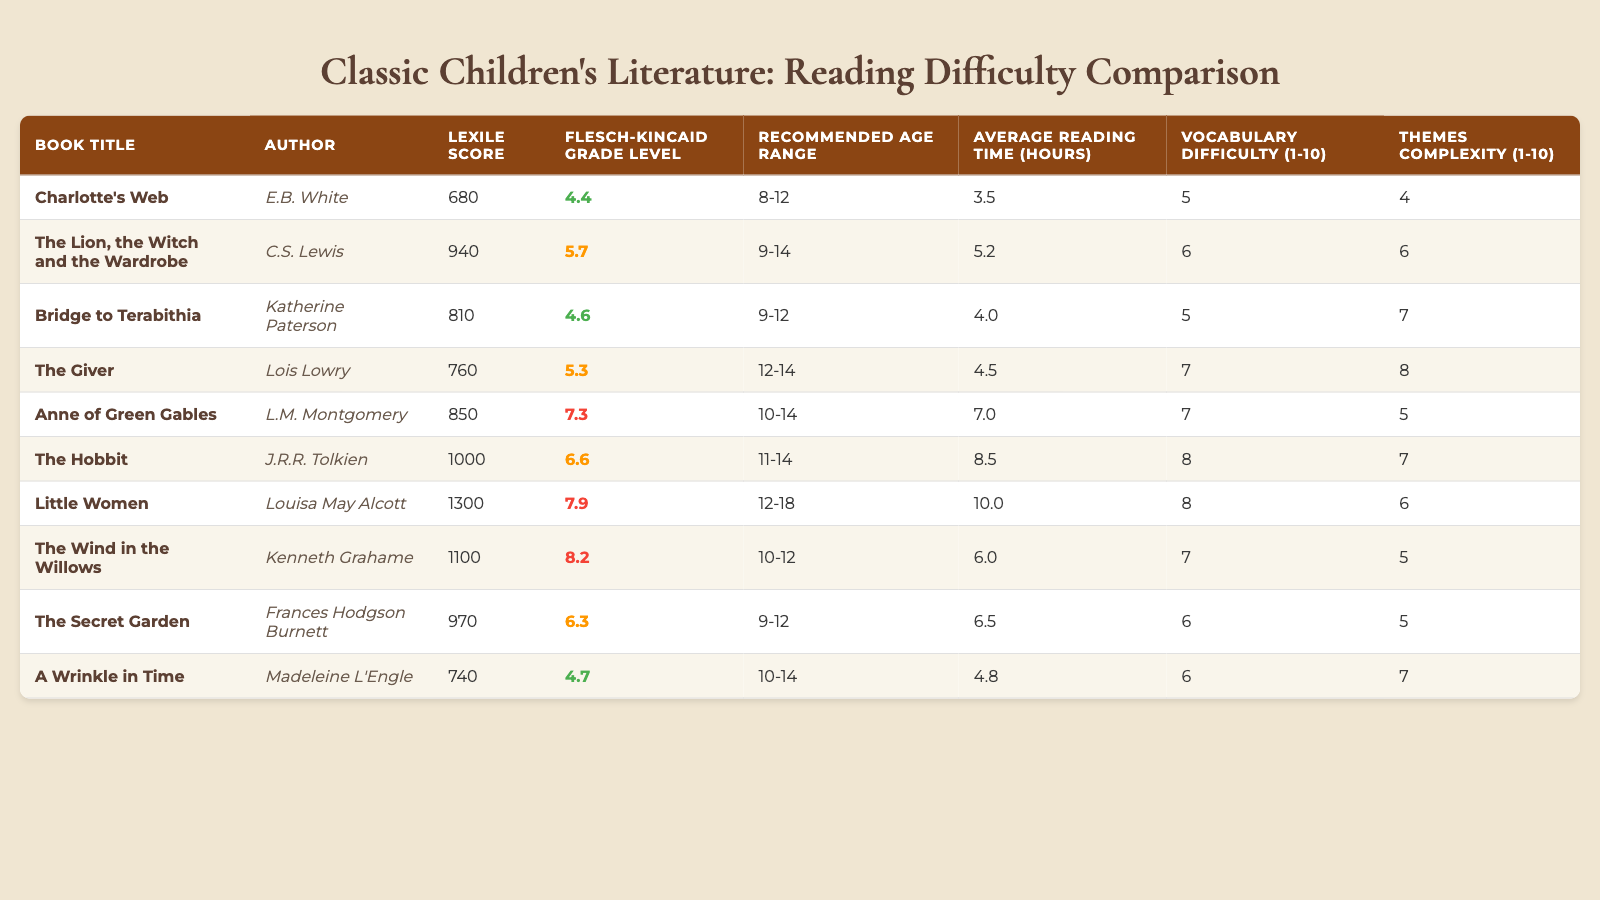What is the Lexile score of "Charlotte's Web"? The Lexile score for "Charlotte's Web" is provided in the table, where it is listed next to the book title. It is 680.
Answer: 680 Which book has the highest Flesch-Kincaid Grade Level? In the table, the Flesch-Kincaid Grade Levels are compared. "Little Women" has the highest value at 7.9.
Answer: 7.9 Is "The Lion, the Witch and the Wardrobe" suitable for children aged 8-12? The recommended age range for "The Lion, the Witch and the Wardrobe" is 9-14, which does not include age 8. Therefore, it is not suitable for that age range.
Answer: No What is the average reading time for "The Hobbit" and "Little Women"? The reading time for "The Hobbit" is 8.5 hours, and for "Little Women" it is 10.0 hours. Adding these together gives 18.5 hours, and averaging them (18.5/2) results in 9.25 hours.
Answer: 9.25 How many books have a vocabulary difficulty of 7 or higher? The table lists the vocabulary difficulties, and counting those with a rating of 7 or above, we find "The Giver," "Anne of Green Gables," "The Hobbit," and "Little Women." This results in a total of four books.
Answer: 4 What is the difference in Lexile scores between "A Wrinkle in Time" and "Charlotte's Web"? The Lexile score for "A Wrinkle in Time" is 740 and for "Charlotte's Web" it is 680. The difference is 740 - 680 = 60.
Answer: 60 Which book has the lowest Vocabulary Difficulty score? Looking at the "Vocabulary Difficulty" column, both "Charlotte's Web" and "Bridge to Terabithia" have a score of 5, which is the lowest in the table.
Answer: 5 What is the recommended age range for books with a Themes Complexity score of 6 or higher? Analyzing the "Themes Complexity" column, the books with a score of 6 or higher are "The Lion, the Witch and the Wardrobe," "Bridge to Terabithia," "The Hobbit," and "Little Women." Their respective recommended age ranges are 9-14, 9-12, 11-14, and 12-18.
Answer: 9-14, 9-12, 11-14, 12-18 What is the total average reading time for books that fall into the 10-14 age range? The books suitable for the 10-14 age range are "Anne of Green Gables," "The Hobbit," and "A Wrinkle in Time." Their reading times are 7.0, 8.5, and 4.8 hours respectively. Summing these gives 20.3 hours, and averaging with 3 books results in 20.3/3 = approximately 6.77 hours.
Answer: 6.77 